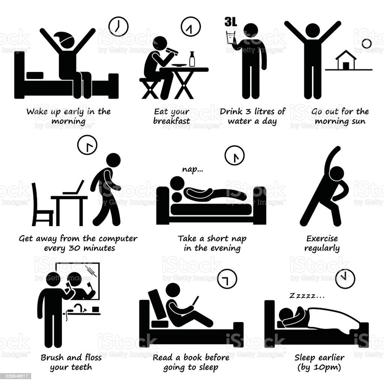What is the suggested bedtime in the image? The image explicitly suggests a bedtime regime, advising to sleep earlier, ideally by 10 pm. This routine is visually reinforced by depicting a peaceful sleeping environment conducive to good health. 